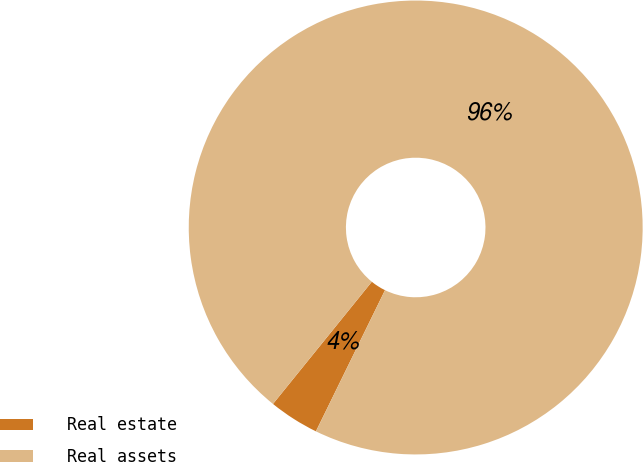Convert chart to OTSL. <chart><loc_0><loc_0><loc_500><loc_500><pie_chart><fcel>Real estate<fcel>Real assets<nl><fcel>3.58%<fcel>96.42%<nl></chart> 